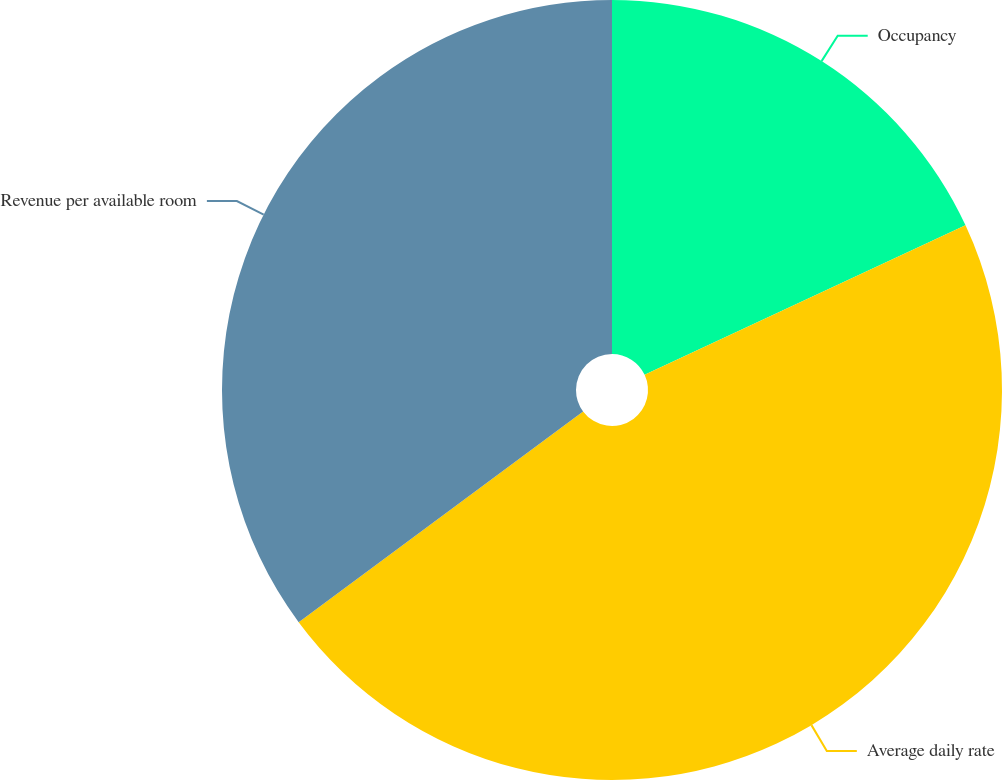<chart> <loc_0><loc_0><loc_500><loc_500><pie_chart><fcel>Occupancy<fcel>Average daily rate<fcel>Revenue per available room<nl><fcel>18.06%<fcel>46.79%<fcel>35.15%<nl></chart> 